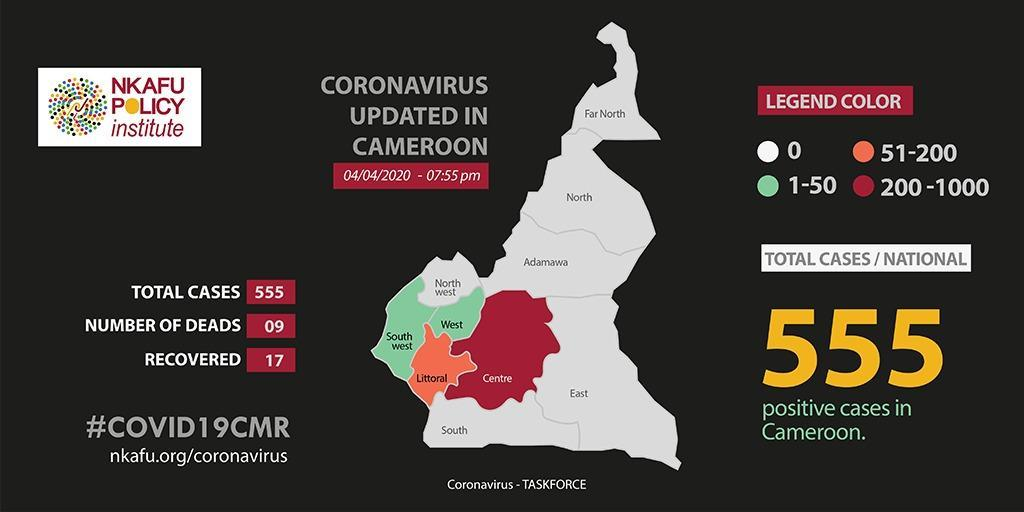What is the range of  COVID-19 cases in the Littoral region of Cameroon as of 04/04/2020?
Answer the question with a short phrase. 51-200 What is the total number of positive cases of Covid-19 reported in Cameroon as of 04/04/2020? 555 How many Covid-19 deaths were reported in Cameroon as of 04/04/2020? 09 What is the range of COVID-19 cases in the Adamawa region of Cameroon as of 04/04/2020? 0 What is the range of COVID-19 cases in the south west region of Cameroon as of 04/04/2020? 1-50 